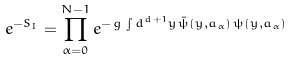Convert formula to latex. <formula><loc_0><loc_0><loc_500><loc_500>e ^ { - S _ { I } } = \prod _ { \alpha = 0 } ^ { N - 1 } e ^ { - \, g \, \int d ^ { d + 1 } y \, { \bar { \psi } } ( y , a _ { \alpha } ) \, \psi ( y , a _ { \alpha } ) }</formula> 